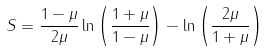Convert formula to latex. <formula><loc_0><loc_0><loc_500><loc_500>S = \frac { 1 - \mu } { 2 \mu } \ln \left ( \frac { 1 + \mu } { 1 - \mu } \right ) - \ln \left ( \frac { 2 \mu } { 1 + \mu } \right )</formula> 